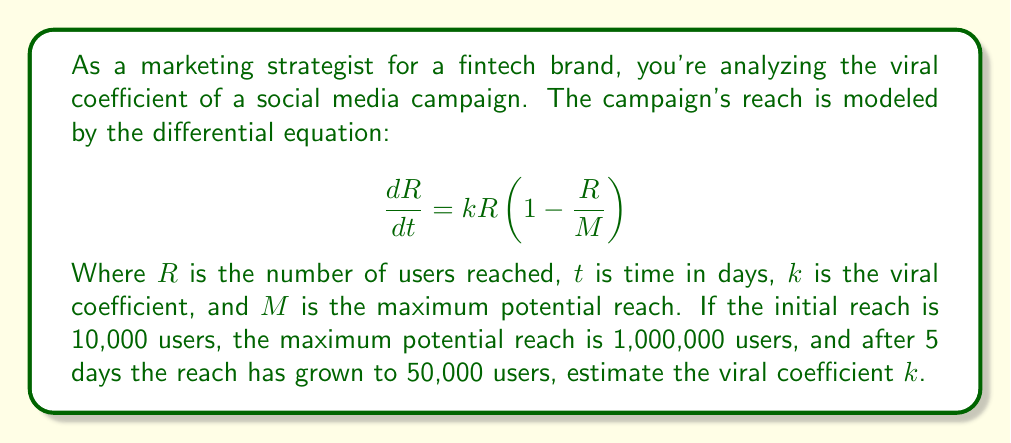Help me with this question. To solve this problem, we'll follow these steps:

1) The given differential equation is a logistic growth model. We need to solve it to find an expression for $R(t)$.

2) The solution to the logistic differential equation is:

   $$R(t) = \frac{M}{1 + (\frac{M}{R_0} - 1)e^{-kt}}$$

   Where $R_0$ is the initial reach.

3) We're given:
   - $R_0 = 10,000$
   - $M = 1,000,000$
   - $R(5) = 50,000$
   - $t = 5$

4) Let's substitute these values into our equation:

   $$50,000 = \frac{1,000,000}{1 + (\frac{1,000,000}{10,000} - 1)e^{-5k}}$$

5) Simplify:

   $$50,000 = \frac{1,000,000}{1 + 99e^{-5k}}$$

6) Solve for $e^{-5k}$:

   $$\frac{1,000,000}{50,000} = 1 + 99e^{-5k}$$
   $$20 = 1 + 99e^{-5k}$$
   $$19 = 99e^{-5k}$$
   $$\frac{19}{99} = e^{-5k}$$

7) Take the natural log of both sides:

   $$\ln(\frac{19}{99}) = -5k$$

8) Solve for $k$:

   $$k = -\frac{1}{5}\ln(\frac{19}{99}) \approx 0.3329$$

Therefore, the estimated viral coefficient is approximately 0.3329.
Answer: $k \approx 0.3329$ 